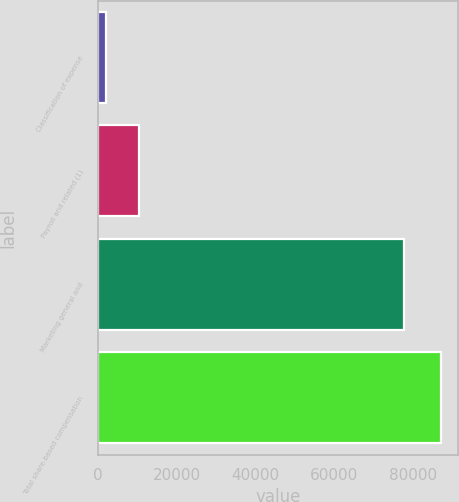Convert chart. <chart><loc_0><loc_0><loc_500><loc_500><bar_chart><fcel>Classification of expense<fcel>Payroll and related (1)<fcel>Marketing general and<fcel>Total share-based compensation<nl><fcel>2017<fcel>10519.2<fcel>77584<fcel>87039<nl></chart> 